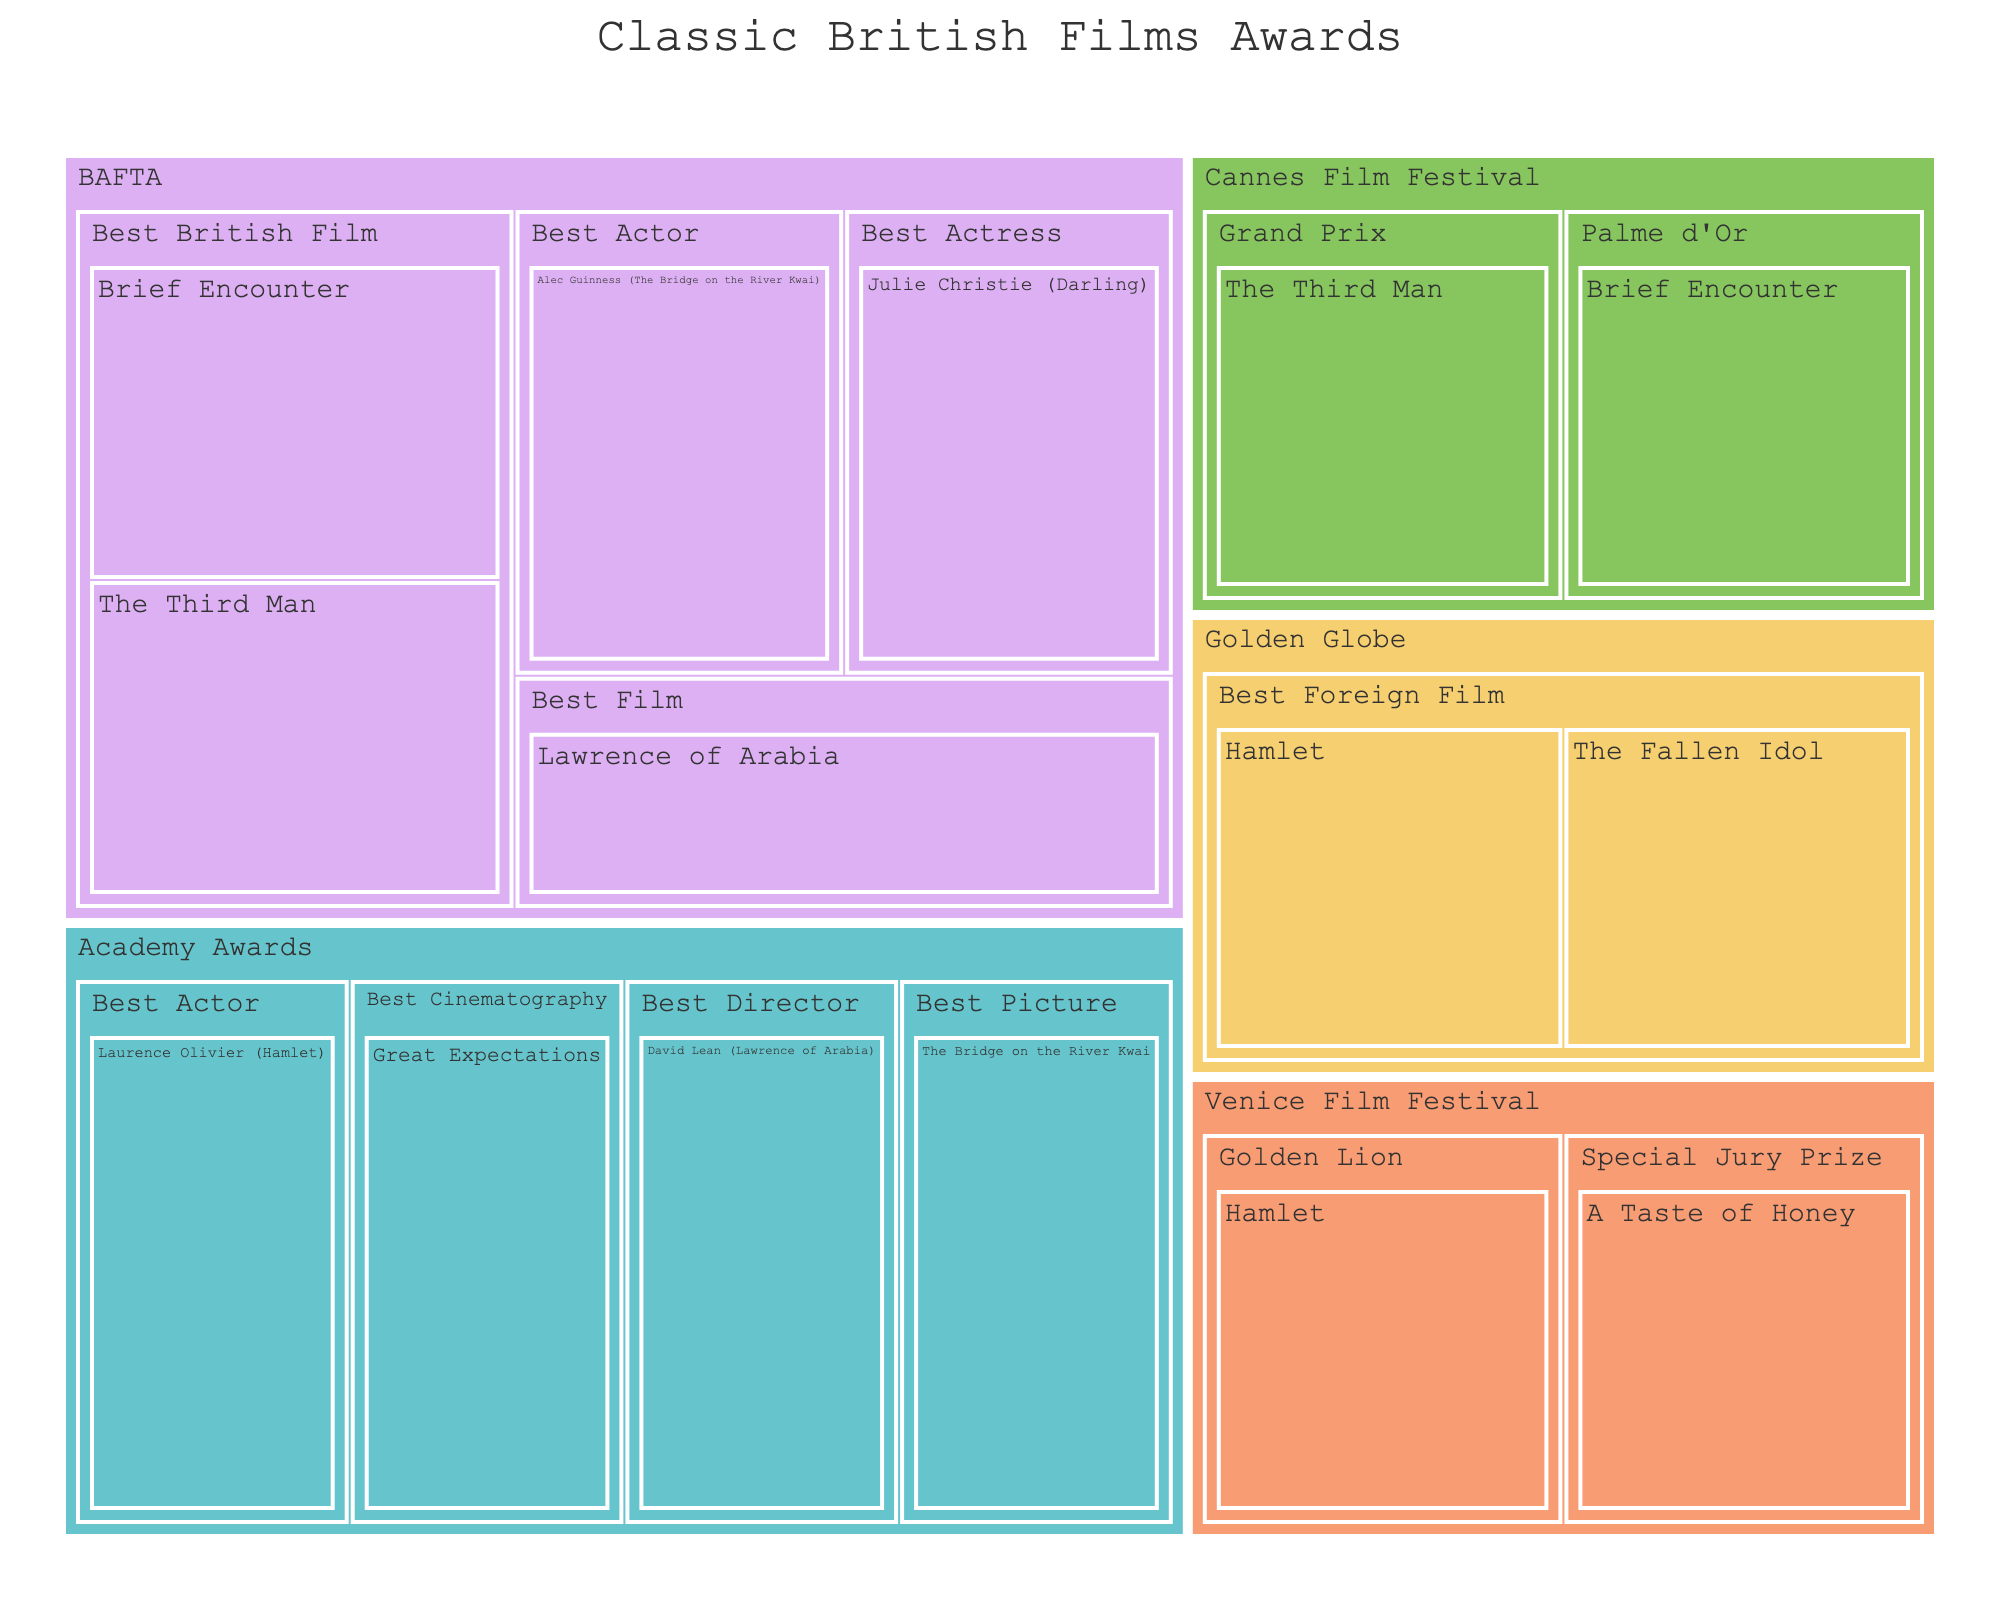What's the title of the figure? The title is usually placed at the top of a plot in a larger or bold font. For this figure, the title displayed is "Classic British Films Awards".
Answer: Classic British Films Awards Which award ceremony has the most categories shown in the figure? To determine this, count the categories under each award ceremony. The BAFTA has five categories, more than the other ceremonies.
Answer: BAFTA Name a film that won a BAFTA award for Best Actress. Look under the BAFTA category for Best Actress to identify the film. Julie Christie (Darling) is listed as the film.
Answer: Julie Christie (Darling) Which film has won the Palme d'Or at Cannes Film Festival? Under the Cannes Film Festival section, look for the category Palme d'Or and identify the film listed there. The film is Brief Encounter.
Answer: Brief Encounter How many films have won at the Venice Film Festival? Count the number of films listed under the Venice Film Festival section. There are two films: Hamlet and A Taste of Honey.
Answer: 2 Which film won both a BAFTA and an Academy Award? Identify films listed under both the BAFTA and Academy Awards sections. The Bridge on the River Kwai won a BAFTA for Best Actor and an Academy Award for Best Picture.
Answer: The Bridge on the River Kwai Compare the number of films that won at Golden Globe and Venice Film Festival. Count the films in each ceremony section. There are two films in the Golden Globe section and two in the Venice Film Festival section. Both have the same number.
Answer: Same number Which award ceremony recognized the most films for Best Foreign Film? This requires noting the categories under each award ceremony. Golden Globe has Best Foreign Film for both Hamlet and The Fallen Idol.
Answer: Golden Globe Name all the categories under the BAFTA award ceremony. List the categories appearing under the BAFTA section: Best British Film, Best Film, Best Actor, Best Actress.
Answer: Best British Film, Best Film, Best Actor, Best Actress For which category did David Lean win an Academy Award? Look under the Academy Awards section for David Lean. The category listed is Best Director.
Answer: Best Director 